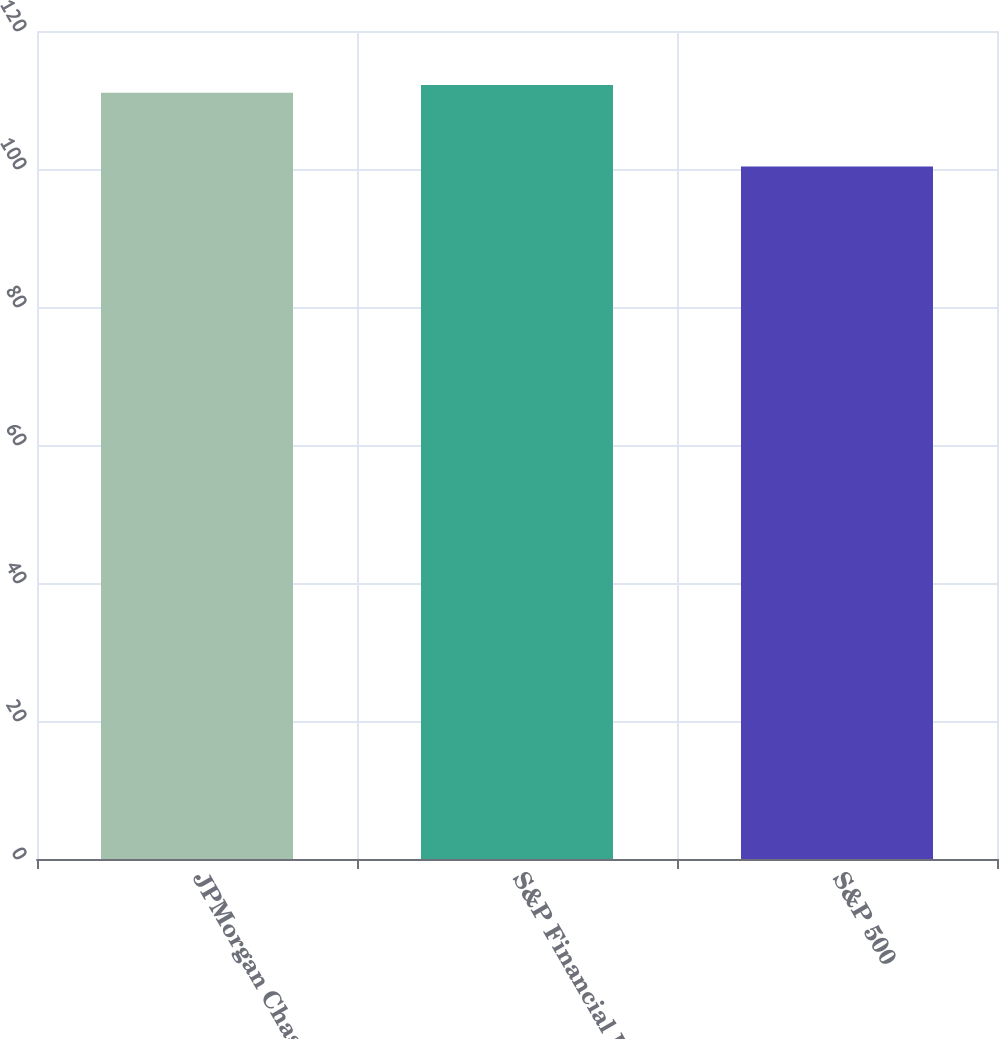Convert chart. <chart><loc_0><loc_0><loc_500><loc_500><bar_chart><fcel>JPMorgan Chase<fcel>S&P Financial Index<fcel>S&P 500<nl><fcel>111.06<fcel>112.16<fcel>100.37<nl></chart> 